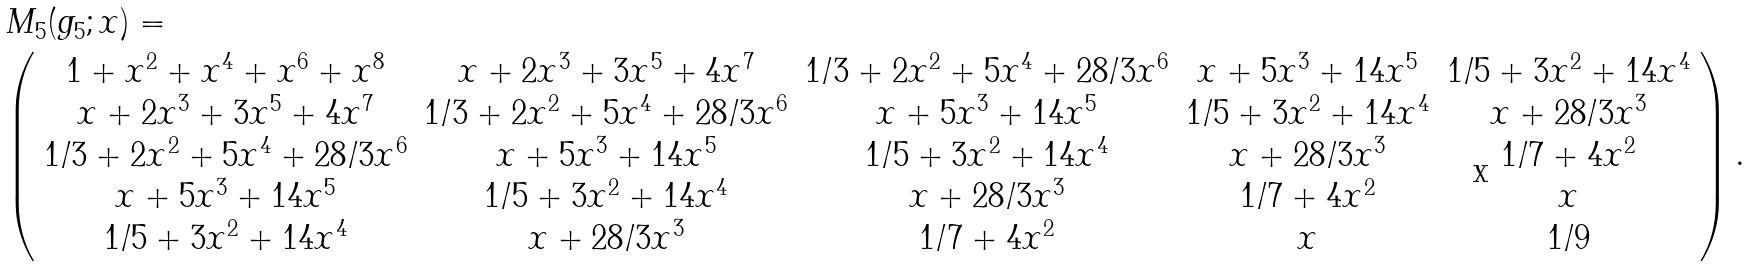Convert formula to latex. <formula><loc_0><loc_0><loc_500><loc_500>& M _ { 5 } ( g _ { 5 } ; x ) = \\ & { \left ( \begin{array} { c c c c c } 1 + x ^ { 2 } + x ^ { 4 } + x ^ { 6 } + x ^ { 8 } & x + 2 x ^ { 3 } + 3 x ^ { 5 } + 4 x ^ { 7 } & 1 / 3 + 2 x ^ { 2 } + 5 x ^ { 4 } + 2 8 / 3 x ^ { 6 } & x + 5 x ^ { 3 } + 1 4 x ^ { 5 } & 1 / 5 + 3 x ^ { 2 } + 1 4 x ^ { 4 } \\ x + 2 x ^ { 3 } + 3 x ^ { 5 } + 4 x ^ { 7 } & 1 / 3 + 2 x ^ { 2 } + 5 x ^ { 4 } + 2 8 / 3 x ^ { 6 } & x + 5 x ^ { 3 } + 1 4 x ^ { 5 } & 1 / 5 + 3 x ^ { 2 } + 1 4 x ^ { 4 } & x + 2 8 / 3 x ^ { 3 } \\ 1 / 3 + 2 x ^ { 2 } + 5 x ^ { 4 } + 2 8 / 3 x ^ { 6 } & x + 5 x ^ { 3 } + 1 4 x ^ { 5 } & 1 / 5 + 3 x ^ { 2 } + 1 4 x ^ { 4 } & x + 2 8 / 3 x ^ { 3 } & 1 / 7 + 4 x ^ { 2 } \\ x + 5 x ^ { 3 } + 1 4 x ^ { 5 } & 1 / 5 + 3 x ^ { 2 } + 1 4 x ^ { 4 } & x + 2 8 / 3 x ^ { 3 } & 1 / 7 + 4 x ^ { 2 } & x \\ 1 / 5 + 3 x ^ { 2 } + 1 4 x ^ { 4 } & x + 2 8 / 3 x ^ { 3 } & 1 / 7 + 4 x ^ { 2 } & x & 1 / 9 \\ \end{array} \right ) . }</formula> 